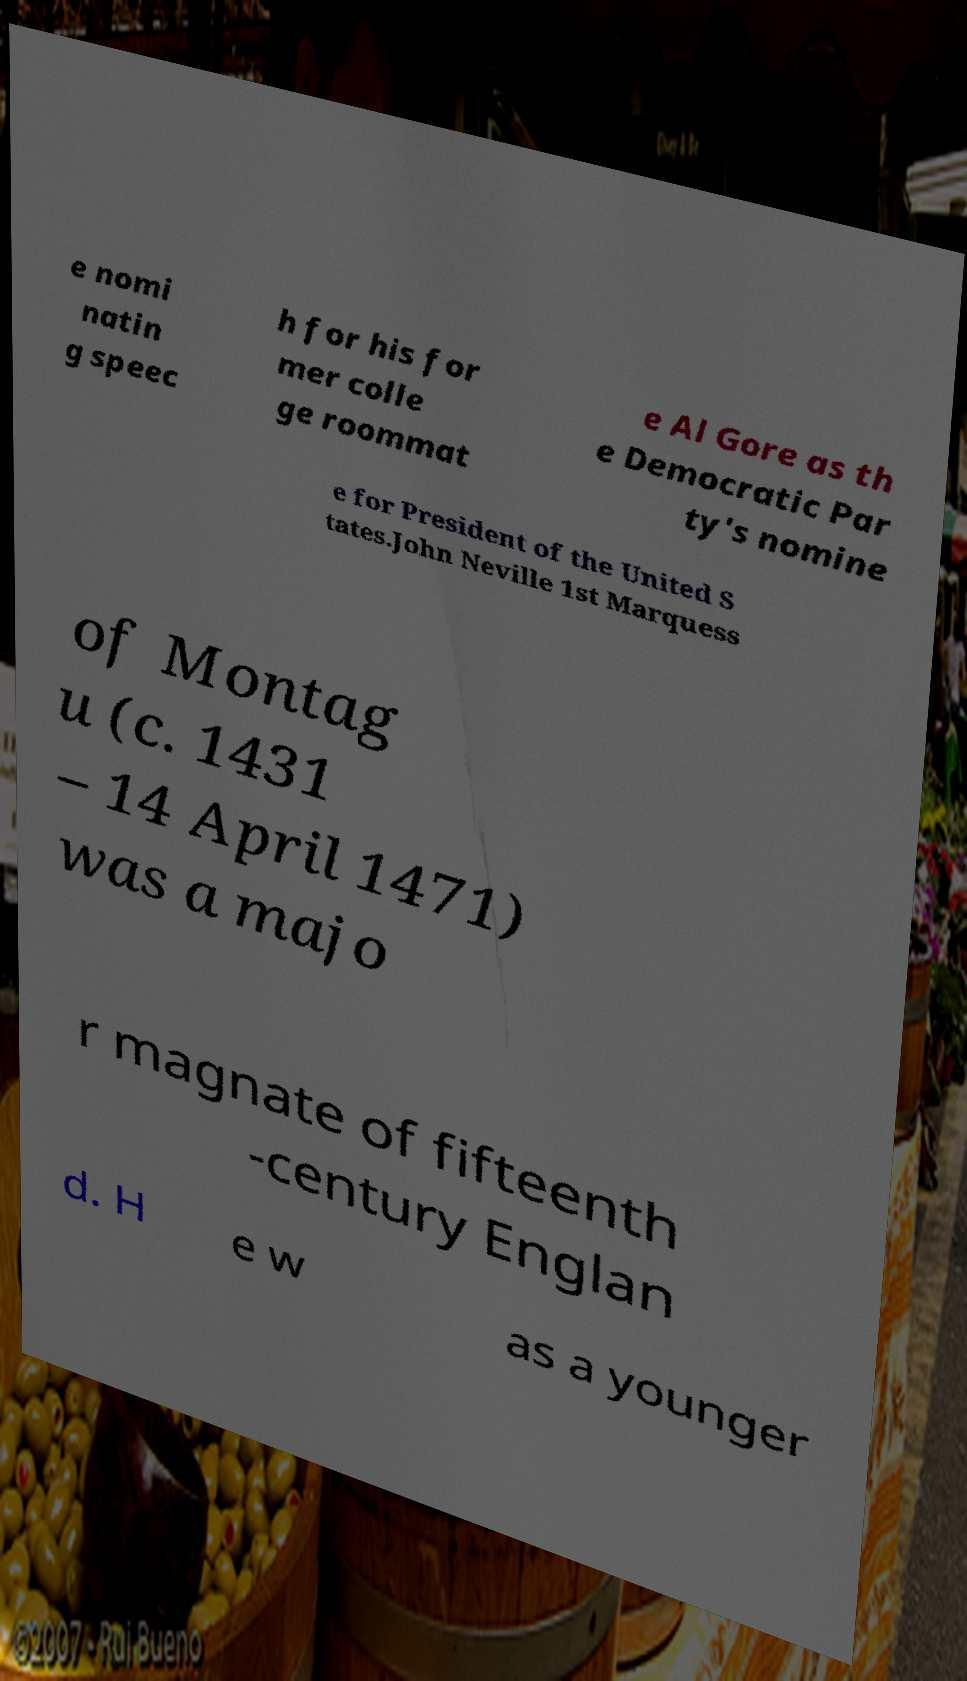There's text embedded in this image that I need extracted. Can you transcribe it verbatim? e nomi natin g speec h for his for mer colle ge roommat e Al Gore as th e Democratic Par ty's nomine e for President of the United S tates.John Neville 1st Marquess of Montag u (c. 1431 – 14 April 1471) was a majo r magnate of fifteenth -century Englan d. H e w as a younger 